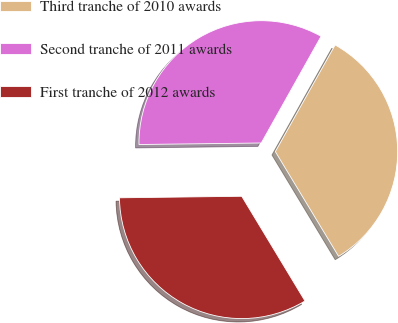Convert chart to OTSL. <chart><loc_0><loc_0><loc_500><loc_500><pie_chart><fcel>Third tranche of 2010 awards<fcel>Second tranche of 2011 awards<fcel>First tranche of 2012 awards<nl><fcel>33.22%<fcel>33.33%<fcel>33.45%<nl></chart> 